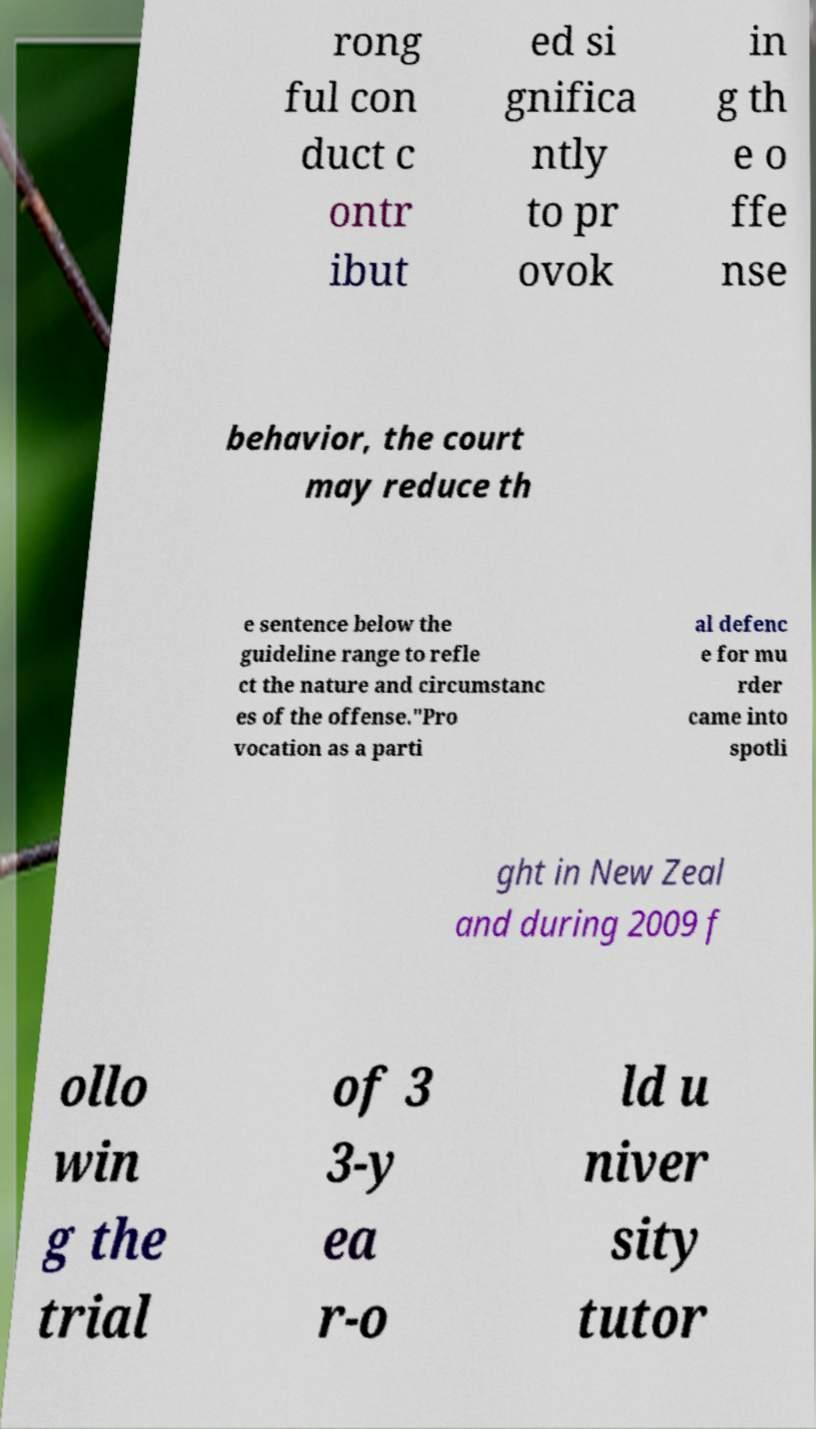Please read and relay the text visible in this image. What does it say? rong ful con duct c ontr ibut ed si gnifica ntly to pr ovok in g th e o ffe nse behavior, the court may reduce th e sentence below the guideline range to refle ct the nature and circumstanc es of the offense."Pro vocation as a parti al defenc e for mu rder came into spotli ght in New Zeal and during 2009 f ollo win g the trial of 3 3-y ea r-o ld u niver sity tutor 